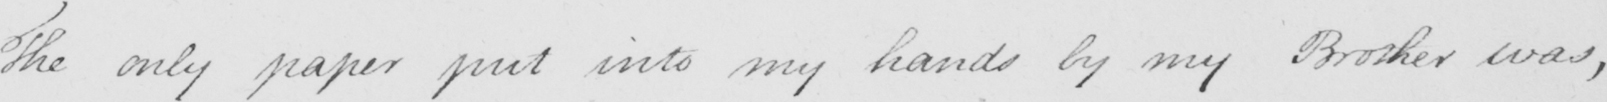What does this handwritten line say? The only paper put into my hands by my Brother was , 